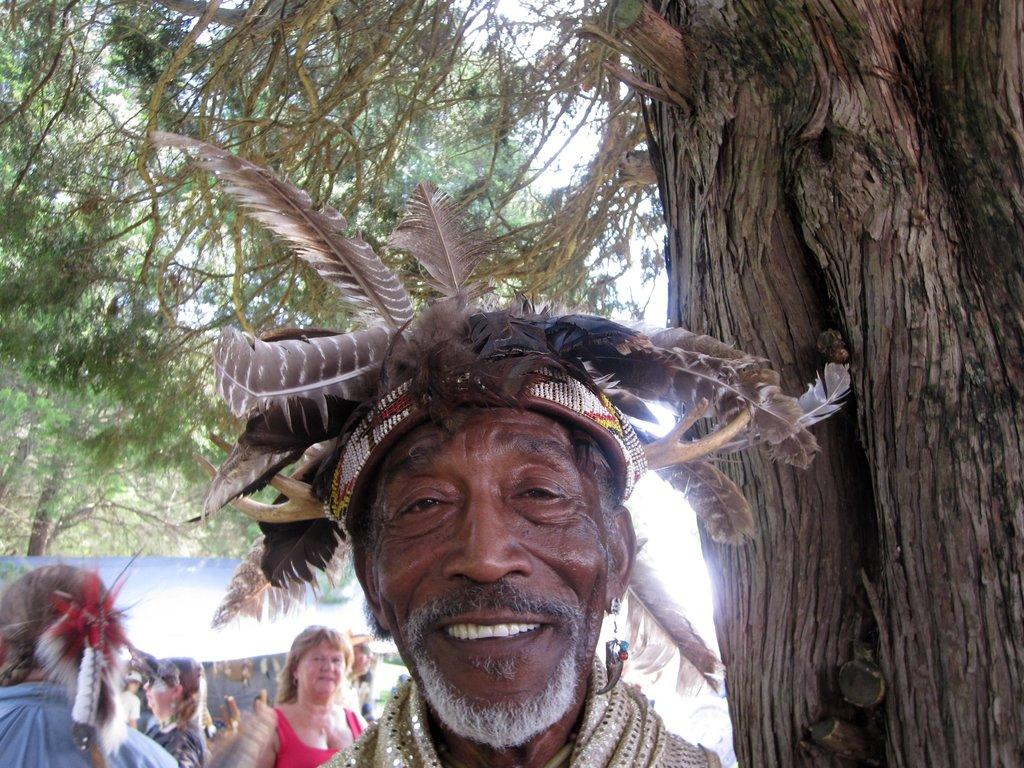What is unique about the person in the image? The person in the image has feathers. How does the person appear to feel in the image? The person is smiling. What can be seen in the background of the image? There is a group of people standing, a stall, and trees in the background of the image. What type of muscle is being exercised by the person in the image? There is no indication in the image that the person is exercising any muscles. How does the person's digestion appear to be affected by the feathers in the image? The image does not provide any information about the person's digestion, and the presence of feathers does not have any direct impact on digestion. 